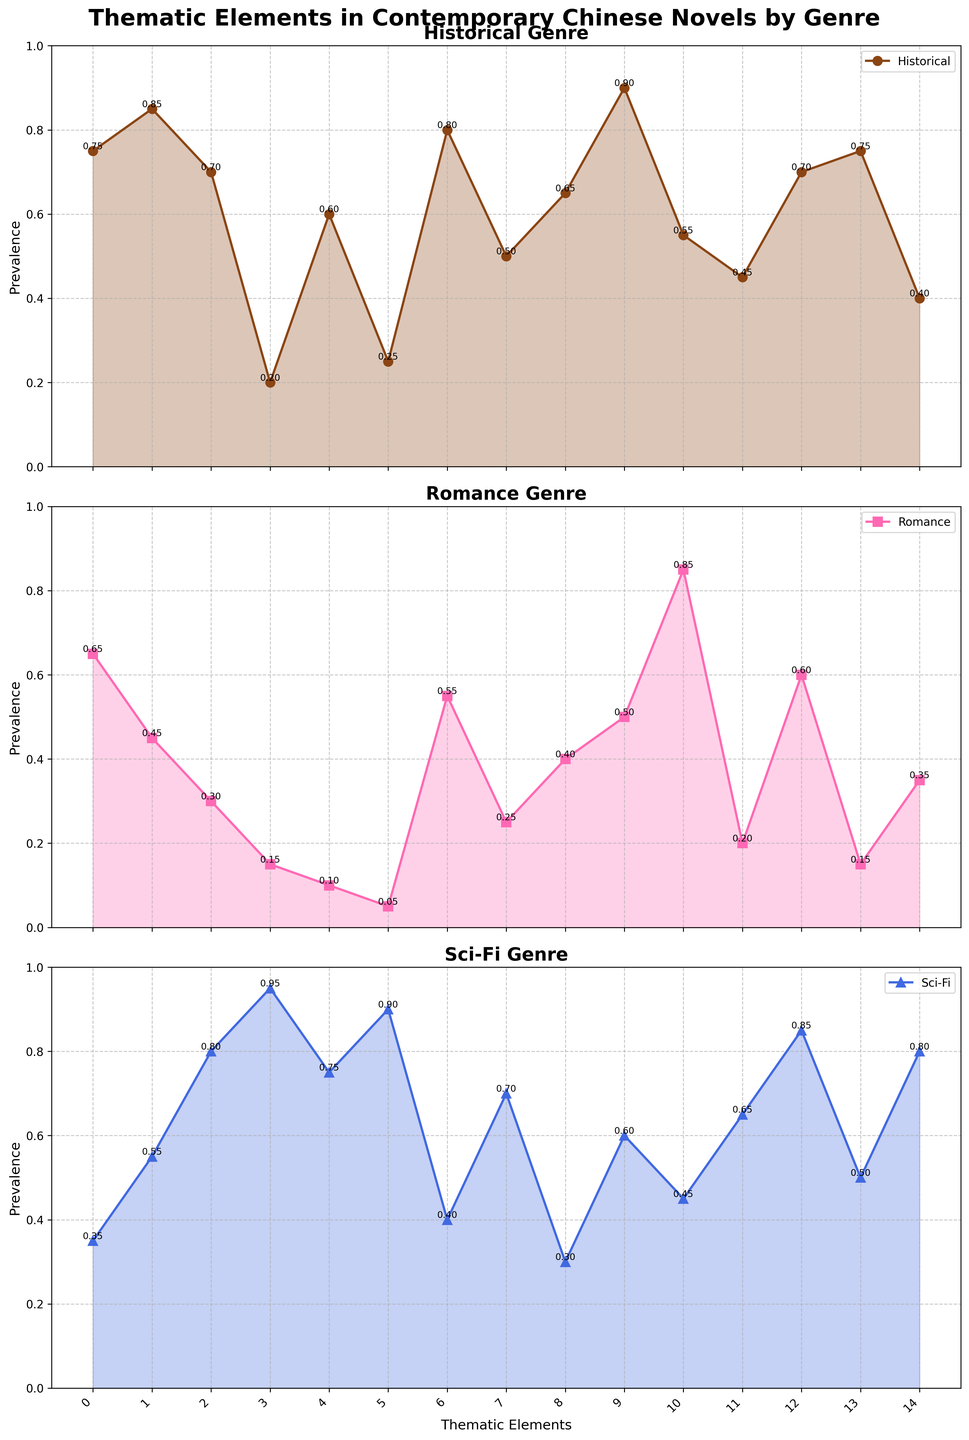What is the most prevalent thematic element in the Historical genre? Looking at the plots, the highest point on the Historical genre subplot represents the thematic element with the highest prevalence.
Answer: Tradition vs Modernity Which genre places the least emphasis on 'Environmental Concerns'? To find this, compare the height of 'Environmental Concerns' across all three subplots and determine which is the smallest.
Answer: Romance What is the difference in prevalence of 'Cultural Identity' between Historical and Romance genres? Refer to the heights of the 'Cultural Identity' points in both Historical and Romance subplots. Subtract the value for Romance from the value for Historical. Specific values are 0.85 for Historical and 0.45 for Romance, so 0.85 - 0.45 = 0.40.
Answer: 0.40 Which genre emphasizes 'Technological Impact' the most? Compare the height of the 'Technological Impact' point across all three subplots to see which is the highest.
Answer: Sci-Fi How does the prevalence of 'Individual vs Society' compare between Romance and Sci-Fi genres? Look at the points for 'Individual vs Society' in both Romance and Sci-Fi subplots. Romance has 0.60 and Sci-Fi has 0.85. Sci-Fi has a higher prevalence.
Answer: Sci-Fi What is the average prevalence of 'Political Critique' across all genres? Add the values for 'Political Critique' from all three subplots (Historical: 0.60, Romance: 0.10, Sci-Fi: 0.75) and divide the sum by 3. (0.60 + 0.10 + 0.75)/3 = 0.4833.
Answer: 0.48 In the Historical genre, which thematic element has a higher prevalence, 'Family Dynamics' or 'Social Commentary'? Compare the heights of 'Family Dynamics' and 'Social Commentary' points in the Historical subplot. 'Family Dynamics' is 0.75 and 'Social Commentary' is 0.70, so 'Family Dynamics' is higher.
Answer: Family Dynamics How much more prevalent is 'Gender Roles' in Romance compared to Sci-Fi? Refer to the values for 'Gender Roles' in Romance and Sci-Fi subplots, then subtract Sci-Fi's value from Romance's. Romance has 0.85 and Sci-Fi has 0.45. 0.85 - 0.45 = 0.40.
Answer: 0.40 What thematic element is equally emphasized in the Romance and Sci-Fi genres? Check the subplot points and identify if any thematic element has the same value in both Romance and Sci-Fi genres. None of them have equal values.
Answer: None Which thematic element has the largest discrepancy in prevalence between Historical and Sci-Fi genres, and what is the value of this discrepancy? Calculate the absolute differences for each thematic element between Historical and Sci-Fi values, and find the largest difference. 'Technological Impact' has 0.20 in Historical and 0.95 in Sci-Fi, making difference 0.95 - 0.20 = 0.75, the largest discrepancy.
Answer: Technological Impact, 0.75 